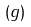Convert formula to latex. <formula><loc_0><loc_0><loc_500><loc_500>( g )</formula> 